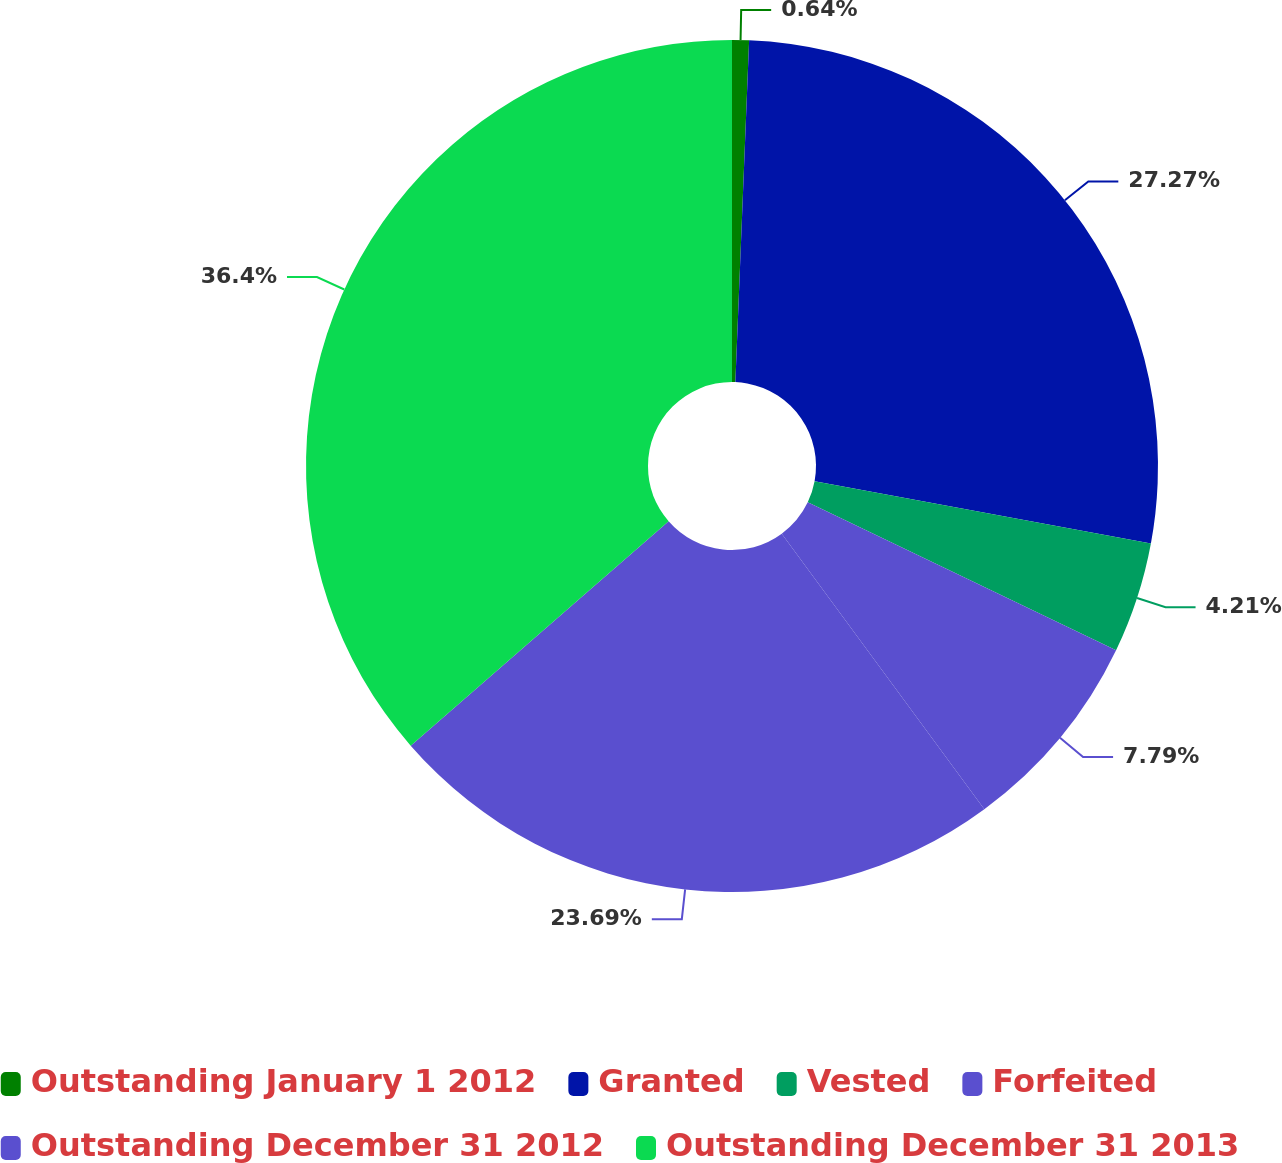Convert chart to OTSL. <chart><loc_0><loc_0><loc_500><loc_500><pie_chart><fcel>Outstanding January 1 2012<fcel>Granted<fcel>Vested<fcel>Forfeited<fcel>Outstanding December 31 2012<fcel>Outstanding December 31 2013<nl><fcel>0.64%<fcel>27.27%<fcel>4.21%<fcel>7.79%<fcel>23.69%<fcel>36.4%<nl></chart> 